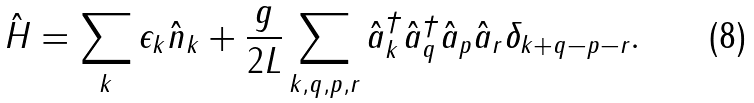<formula> <loc_0><loc_0><loc_500><loc_500>\hat { H } = \sum _ { k } \epsilon _ { k } \hat { n } _ { k } + \frac { g } { 2 L } \sum _ { k , q , p , r } \hat { a } _ { k } ^ { \dag } \hat { a } _ { q } ^ { \dag } \hat { a } _ { p } \hat { a } _ { r } \delta _ { k + q - p - r } .</formula> 